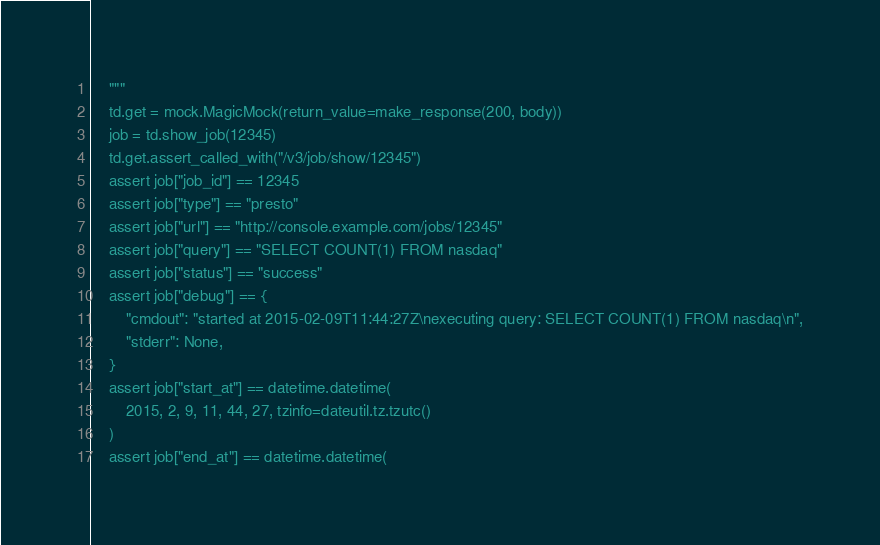Convert code to text. <code><loc_0><loc_0><loc_500><loc_500><_Python_>    """
    td.get = mock.MagicMock(return_value=make_response(200, body))
    job = td.show_job(12345)
    td.get.assert_called_with("/v3/job/show/12345")
    assert job["job_id"] == 12345
    assert job["type"] == "presto"
    assert job["url"] == "http://console.example.com/jobs/12345"
    assert job["query"] == "SELECT COUNT(1) FROM nasdaq"
    assert job["status"] == "success"
    assert job["debug"] == {
        "cmdout": "started at 2015-02-09T11:44:27Z\nexecuting query: SELECT COUNT(1) FROM nasdaq\n",
        "stderr": None,
    }
    assert job["start_at"] == datetime.datetime(
        2015, 2, 9, 11, 44, 27, tzinfo=dateutil.tz.tzutc()
    )
    assert job["end_at"] == datetime.datetime(</code> 